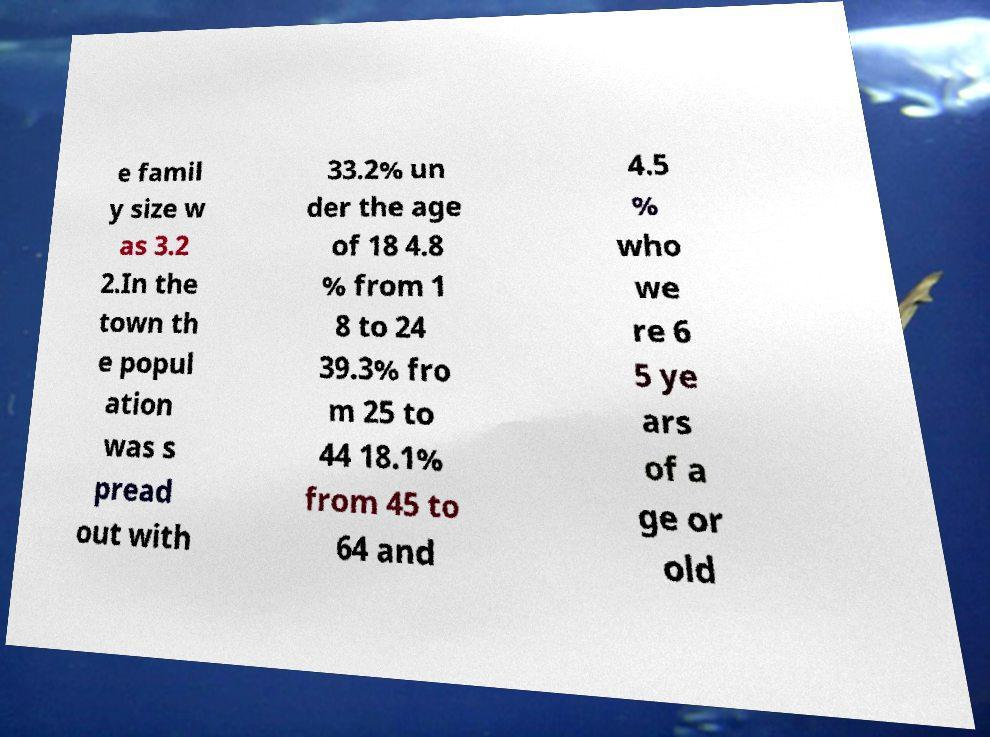Can you accurately transcribe the text from the provided image for me? e famil y size w as 3.2 2.In the town th e popul ation was s pread out with 33.2% un der the age of 18 4.8 % from 1 8 to 24 39.3% fro m 25 to 44 18.1% from 45 to 64 and 4.5 % who we re 6 5 ye ars of a ge or old 